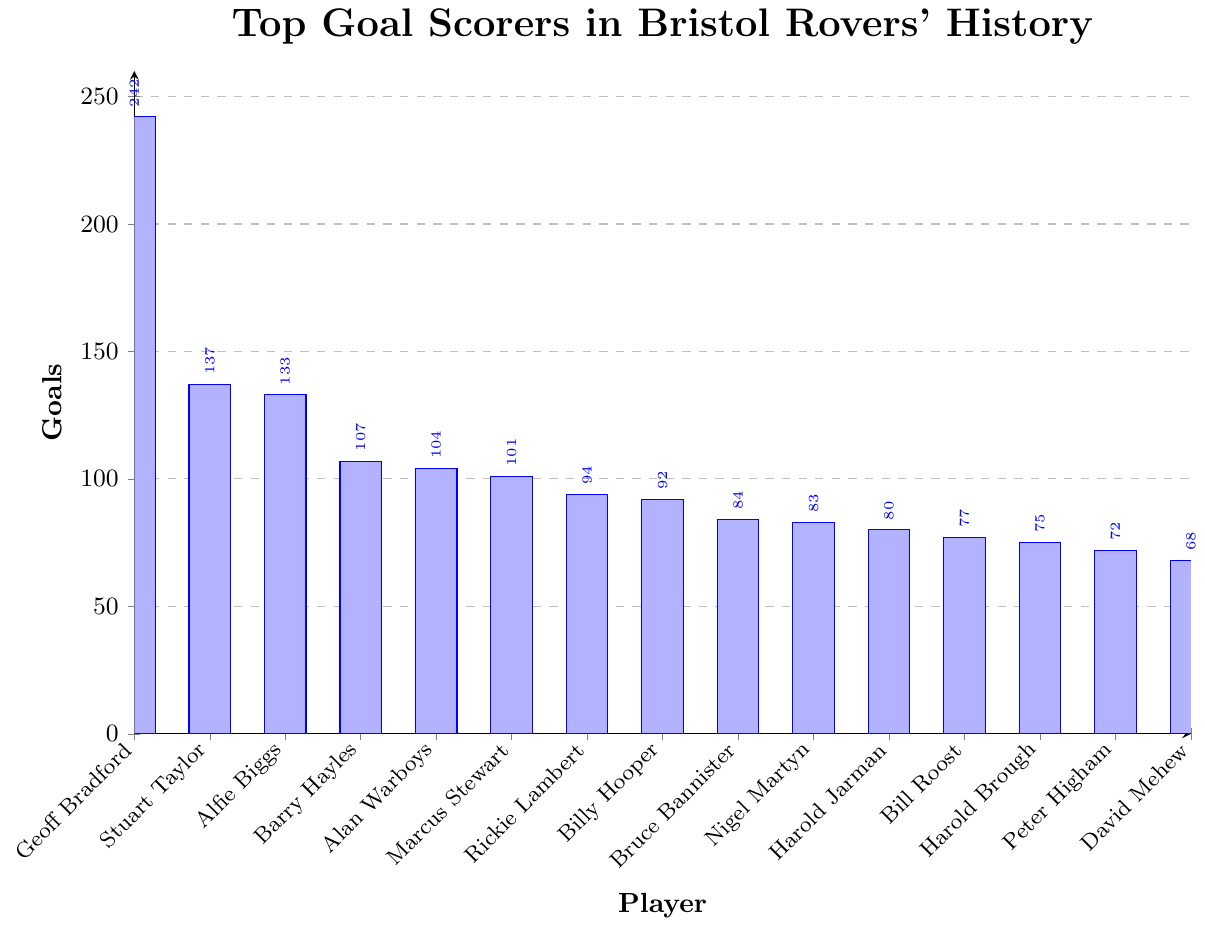Which player scored the second-most goals? Geoff Bradford scored the most with 242 goals. The next highest bar represents Stuart Taylor with 137 goals.
Answer: Stuart Taylor How many goals did Alfie Biggs score more than Rickie Lambert? Alfie Biggs scored 133 goals and Rickie Lambert scored 94 goals. The difference is 133 - 94 = 39.
Answer: 39 What is the total number of goals scored by Geoff Bradford, Alfie Biggs, and Barry Hayles combined? Geoff Bradford scored 242 goals, Alfie Biggs scored 133 goals, and Barry Hayles scored 107 goals. The sum is 242 + 133 + 107 = 482.
Answer: 482 Which player scored the fewest goals among the top Bristol Rovers' scorers? By comparing the heights of the bars, David Mehew scored the fewest with 68 goals, the shortest bar in the chart.
Answer: David Mehew Who scored more goals, Nigel Martyn or Harold Jarman? From the chart, Nigel Martyn scored 83 goals, while Harold Jarman scored 80. Nigel Martyn's bar is slightly higher.
Answer: Nigel Martyn What is the difference in goals between Bruce Bannister and Bill Roost? Bruce Bannister scored 84 goals and Bill Roost scored 77 goals. The difference is 84 - 77 = 7.
Answer: 7 Which players scored around 100 goals? Alan Warboys scored 104 goals and Marcus Stewart scored 101 goals. Both bars are close to the 100 mark.
Answer: Alan Warboys and Marcus Stewart Among the players listed, how many scored more than 90 but less than 100 goals? The chart shows that Rickie Lambert scored 94 goals and Billy Hooper scored 92 goals. Both met the criteria of scoring between 90 and 100 goals.
Answer: 2 Which player scored exactly 72 goals? The bar for Peter Higham represents 72 goals.
Answer: Peter Higham What is the average number of goals scored by the top five goal scorers? The top five scorers are Geoff Bradford (242), Stuart Taylor (137), Alfie Biggs (133), Barry Hayles (107), and Alan Warboys (104). The sum is 242 + 137 + 133 + 107 + 104 = 723. The average is 723 / 5 = 144.6.
Answer: 144.6 